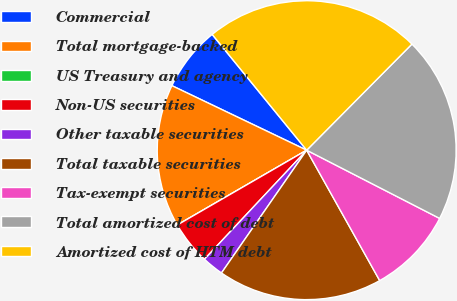Convert chart to OTSL. <chart><loc_0><loc_0><loc_500><loc_500><pie_chart><fcel>Commercial<fcel>Total mortgage-backed<fcel>US Treasury and agency<fcel>Non-US securities<fcel>Other taxable securities<fcel>Total taxable securities<fcel>Tax-exempt securities<fcel>Total amortized cost of debt<fcel>Amortized cost of HTM debt<nl><fcel>7.0%<fcel>15.45%<fcel>0.0%<fcel>4.67%<fcel>2.33%<fcel>17.78%<fcel>9.33%<fcel>20.11%<fcel>23.33%<nl></chart> 